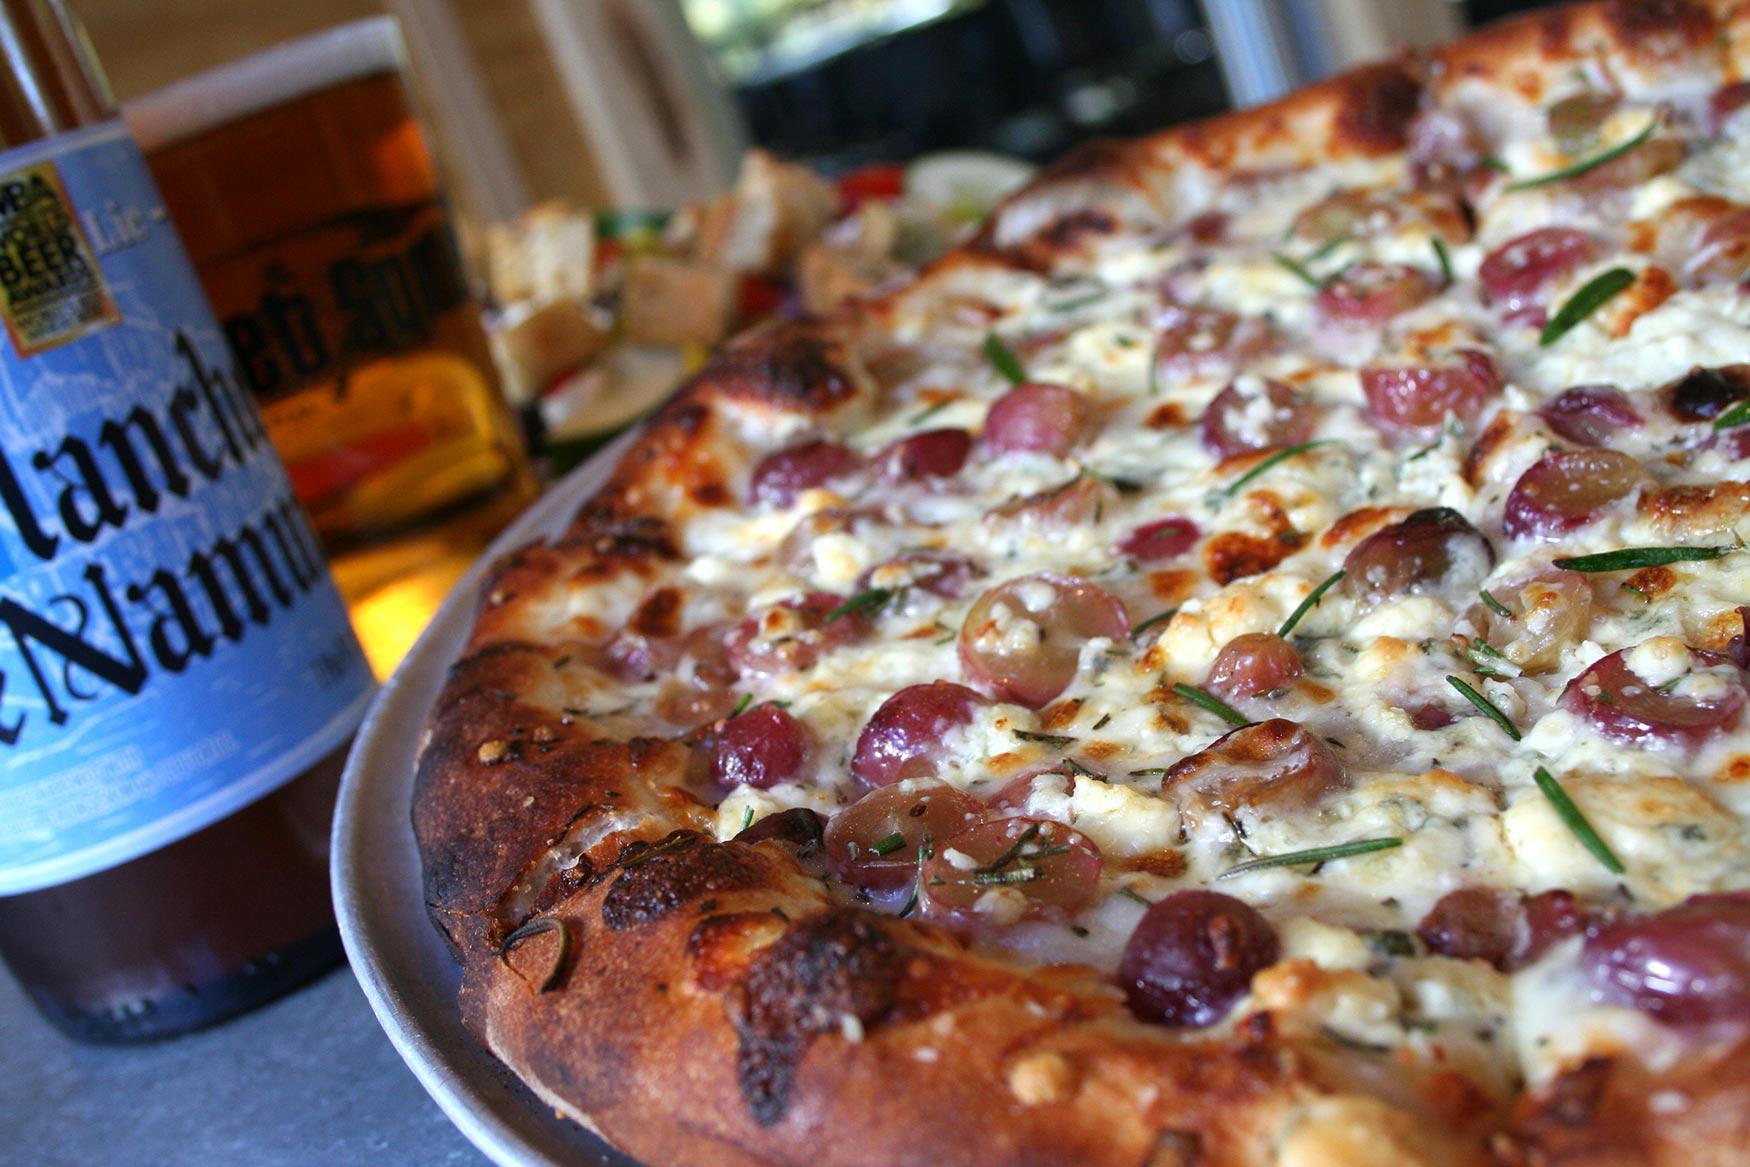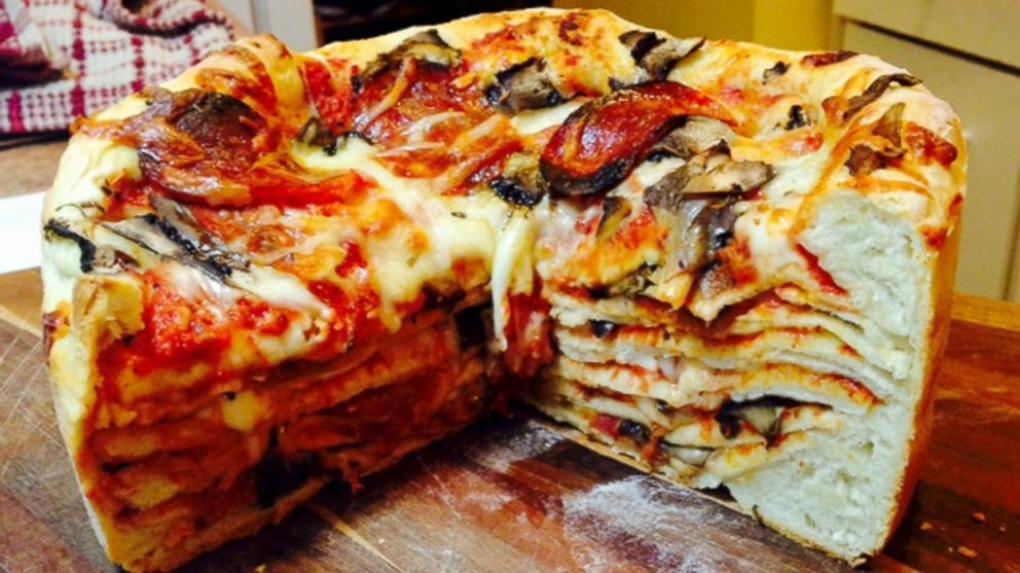The first image is the image on the left, the second image is the image on the right. Analyze the images presented: Is the assertion "In one of the images a piece of pizza pie is missing." valid? Answer yes or no. Yes. The first image is the image on the left, the second image is the image on the right. For the images displayed, is the sentence "A wedge-shaped slice is missing from a deep-dish round 'pie' in one image." factually correct? Answer yes or no. Yes. 